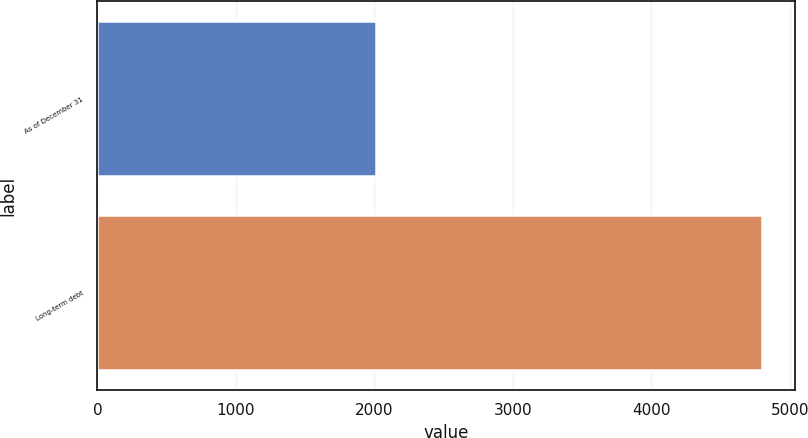Convert chart. <chart><loc_0><loc_0><loc_500><loc_500><bar_chart><fcel>As of December 31<fcel>Long-term debt<nl><fcel>2014<fcel>4799<nl></chart> 